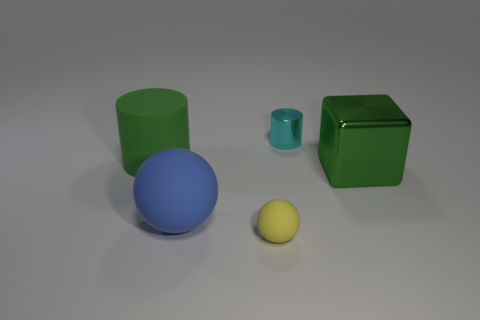What could be the materials of these objects? The objects appear to have a smooth, matte finish which suggests they might be made of materials like plastic or rubber. The matte surface indicates they are non-reflective. 